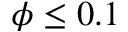<formula> <loc_0><loc_0><loc_500><loc_500>\phi \leq 0 . 1</formula> 